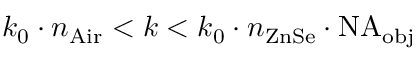<formula> <loc_0><loc_0><loc_500><loc_500>k _ { 0 } \cdot n _ { A i r } < k < k _ { 0 } \cdot n _ { Z n S e } \cdot N A _ { o b j }</formula> 